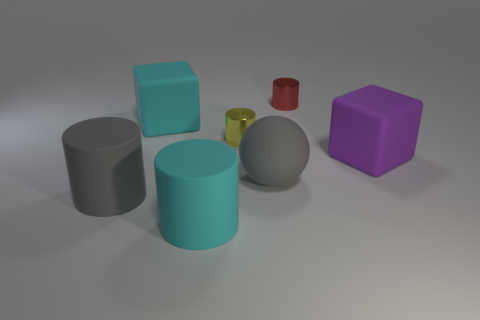Subtract all green cylinders. Subtract all gray cubes. How many cylinders are left? 4 Add 2 large yellow balls. How many objects exist? 9 Subtract all balls. How many objects are left? 6 Subtract 0 green cylinders. How many objects are left? 7 Subtract all yellow things. Subtract all big gray rubber balls. How many objects are left? 5 Add 3 cyan rubber objects. How many cyan rubber objects are left? 5 Add 6 tiny red metallic objects. How many tiny red metallic objects exist? 7 